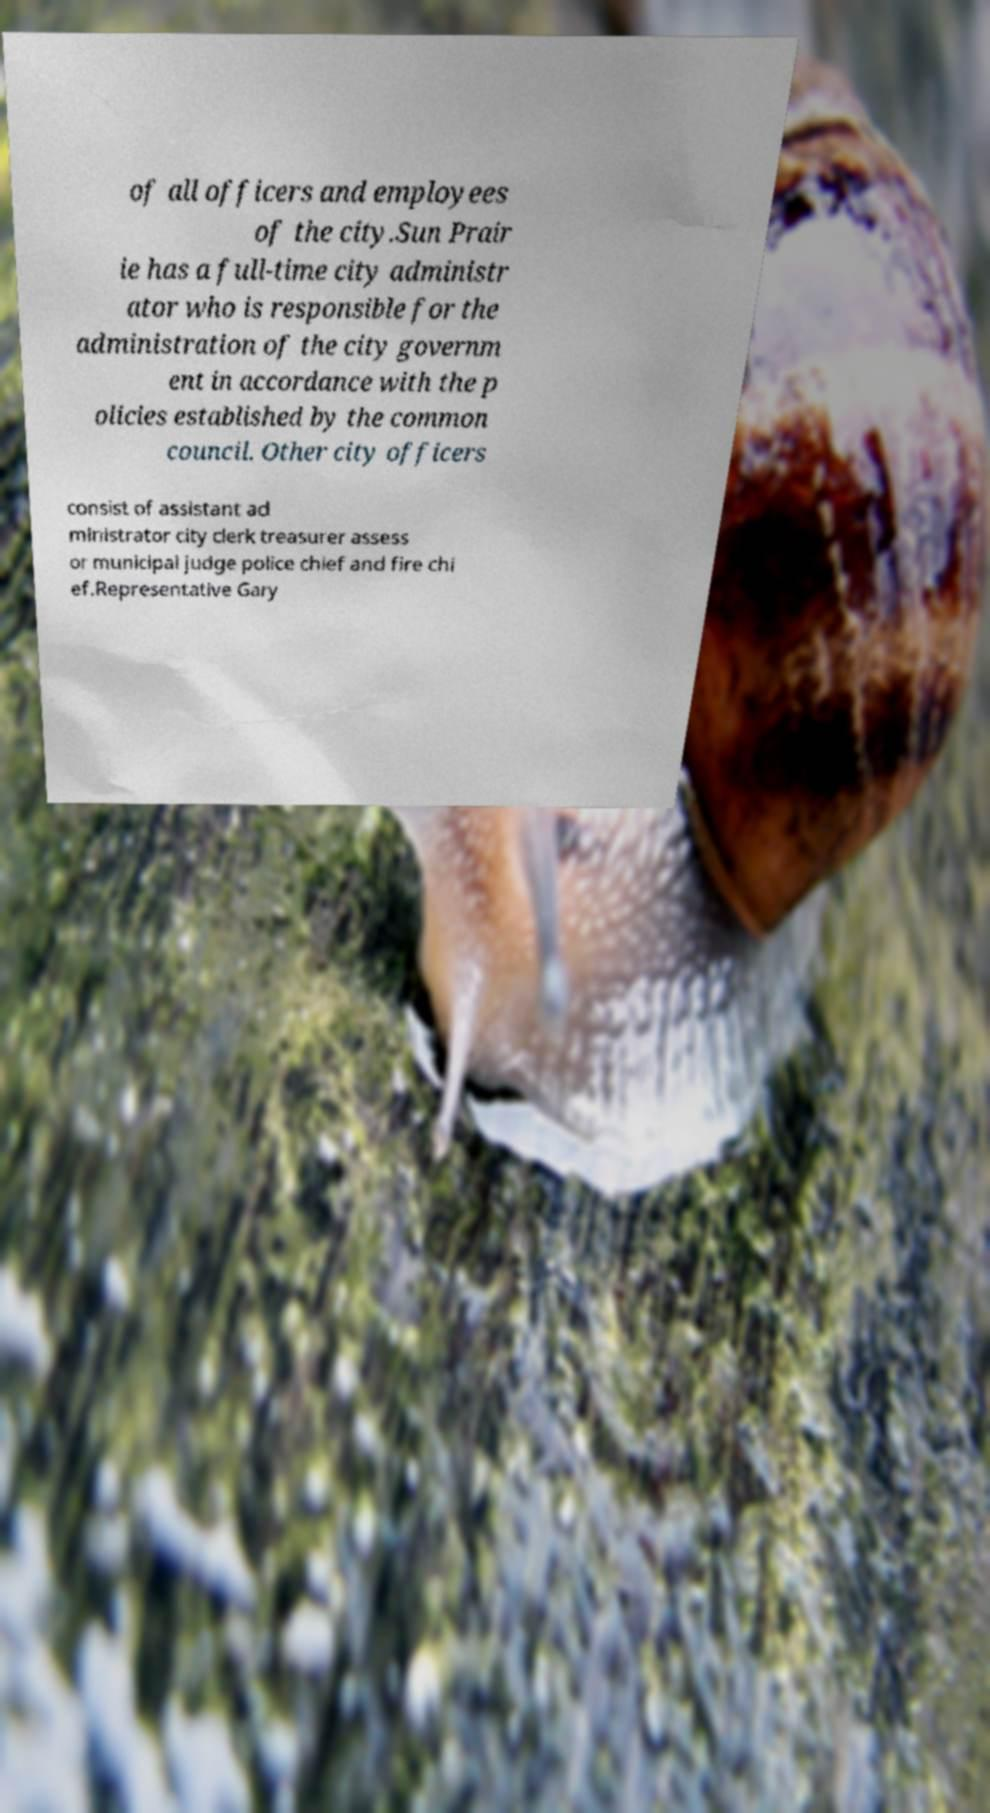Can you accurately transcribe the text from the provided image for me? of all officers and employees of the city.Sun Prair ie has a full-time city administr ator who is responsible for the administration of the city governm ent in accordance with the p olicies established by the common council. Other city officers consist of assistant ad ministrator city clerk treasurer assess or municipal judge police chief and fire chi ef.Representative Gary 